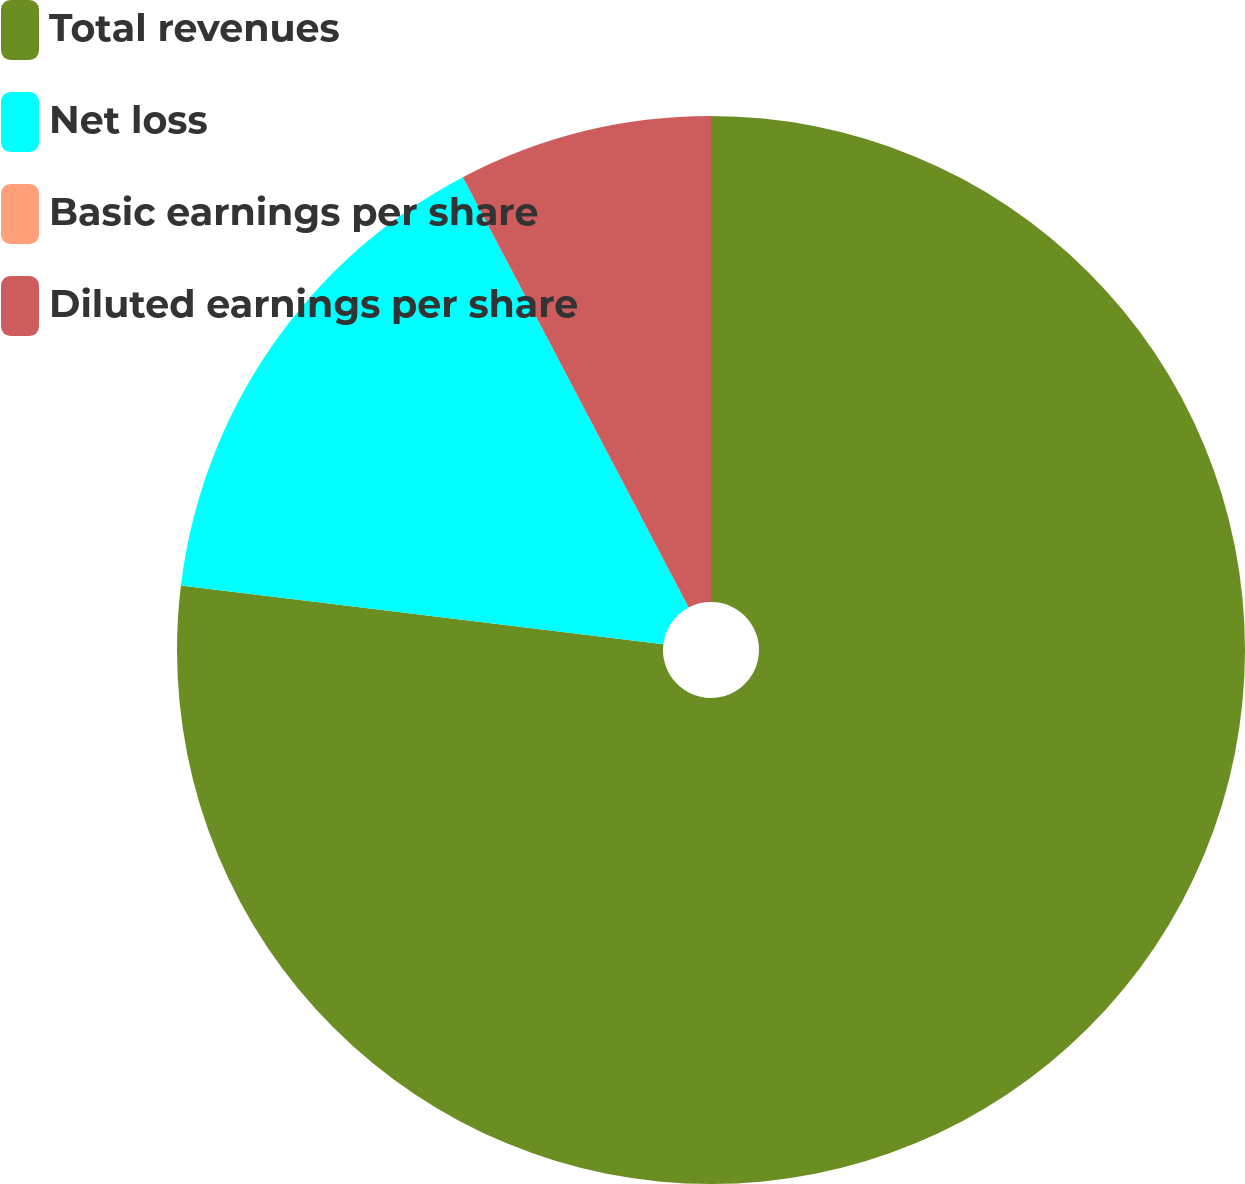<chart> <loc_0><loc_0><loc_500><loc_500><pie_chart><fcel>Total revenues<fcel>Net loss<fcel>Basic earnings per share<fcel>Diluted earnings per share<nl><fcel>76.92%<fcel>15.38%<fcel>0.0%<fcel>7.69%<nl></chart> 